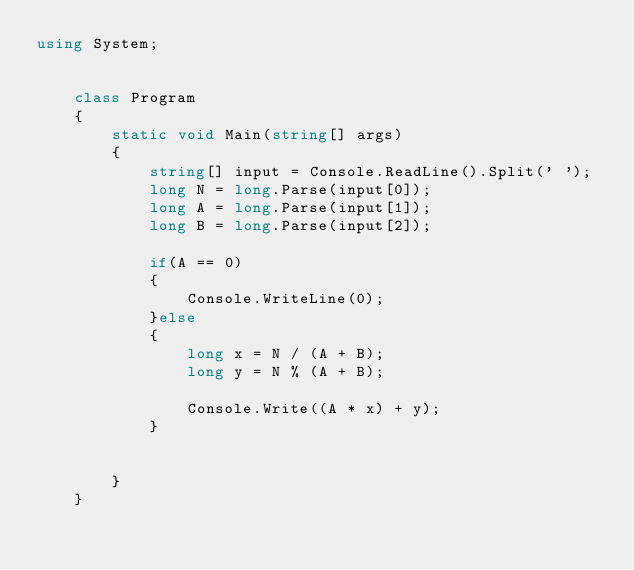<code> <loc_0><loc_0><loc_500><loc_500><_C#_>using System;


    class Program
    {
        static void Main(string[] args)
        {
            string[] input = Console.ReadLine().Split(' ');
            long N = long.Parse(input[0]);
            long A = long.Parse(input[1]);
            long B = long.Parse(input[2]);

            if(A == 0)
            {
                Console.WriteLine(0);
            }else
            {
                long x = N / (A + B);
                long y = N % (A + B);

                Console.Write((A * x) + y);
            }
                

        }
    }</code> 